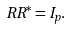<formula> <loc_0><loc_0><loc_500><loc_500>R R ^ { * } = I _ { p } .</formula> 